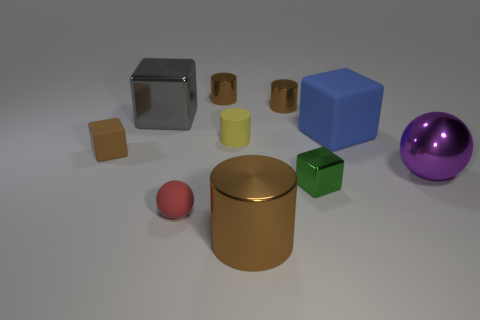Which object stands out the most to you, and why? The purple sphere stands out the most, due to its vibrant color and the way its reflective surface catches the light, contrasting with the other more muted colors and matte textures in the scene. Is there any significance to the sphere's position relative to the other objects? The sphere's position, off to the side of the main cluster of objects, could signify individuality or uniqueness. Its position could also evoke themes of balance and harmony, as it acts as a visual counterpoint to the group of shapes, creating a dynamic interplay between the elements in the image. 